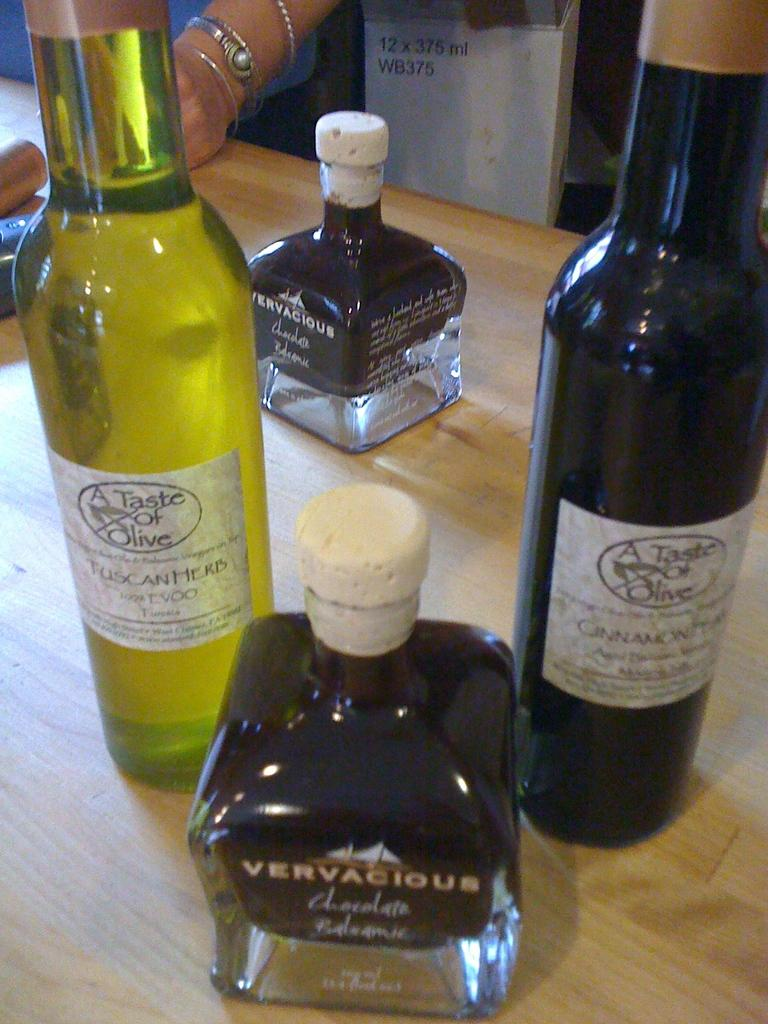<image>
Describe the image concisely. A bottle of Vervacious and two bottles of A Taste of Olive on a wooden table. 